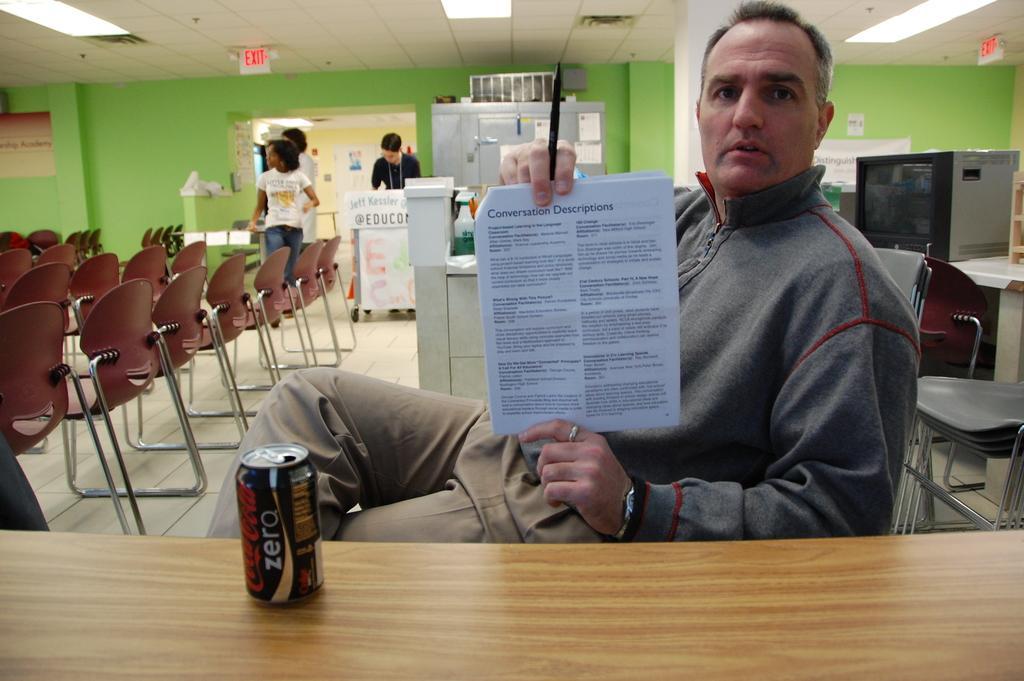How would you summarize this image in a sentence or two? In this picture vacancy a person sitting on a chair in front of him there is a table on the table we can seat in bottle and side of him there are so many chairs are arranged and backside people are standing and there is a micro oven and the man is holding a paper. 